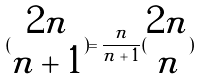<formula> <loc_0><loc_0><loc_500><loc_500>( \begin{matrix} 2 n \\ n + 1 \end{matrix} ) = \frac { n } { n + 1 } ( \begin{matrix} 2 n \\ n \end{matrix} )</formula> 